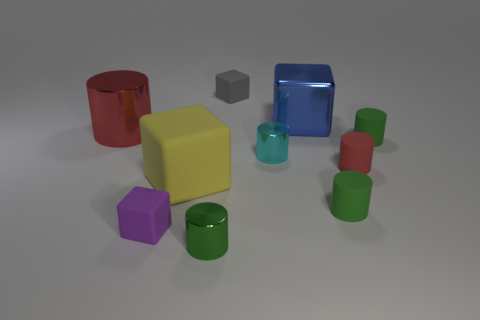Subtract all gray blocks. How many red cylinders are left? 2 Subtract all rubber blocks. How many blocks are left? 1 Subtract 1 blocks. How many blocks are left? 3 Subtract all purple cubes. How many cubes are left? 3 Subtract all red cylinders. Subtract all cyan balls. How many cylinders are left? 4 Subtract all blocks. How many objects are left? 6 Add 7 blue cubes. How many blue cubes are left? 8 Add 1 large cyan balls. How many large cyan balls exist? 1 Subtract 0 brown spheres. How many objects are left? 10 Subtract all large blue objects. Subtract all gray things. How many objects are left? 8 